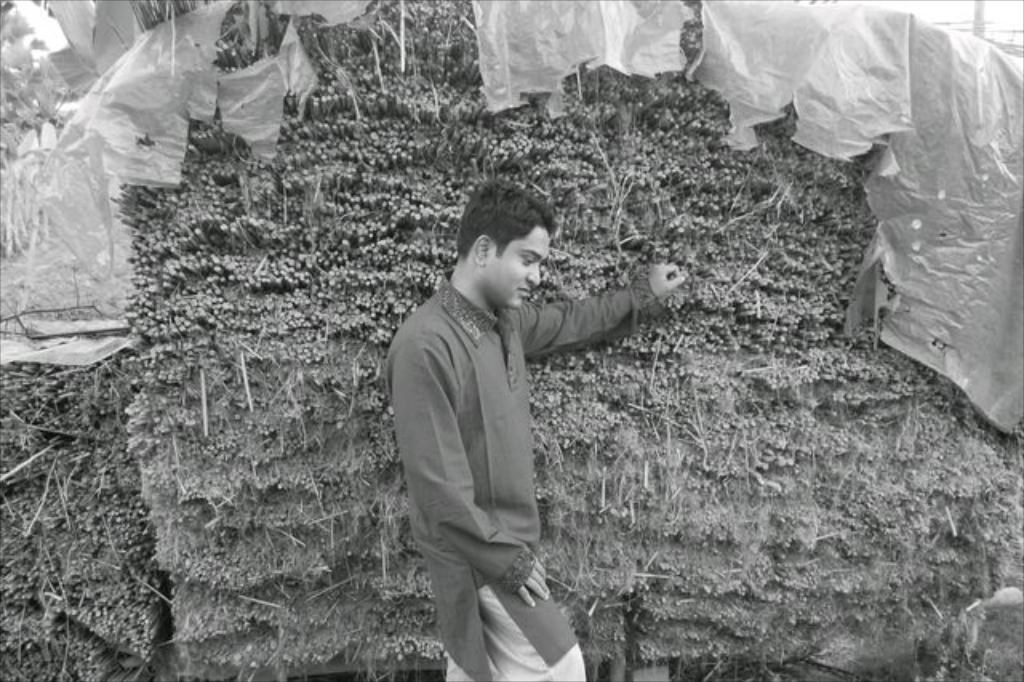Who or what can be seen in the image? There is a person in the image. What is the person doing in the image? The person is resting his hands on objects. Can you describe any specific objects in the image? There is an object with a cover in the image. What type of music is being played by the car in the image? There is no car present in the image, and therefore no music being played by a car. 